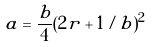Convert formula to latex. <formula><loc_0><loc_0><loc_500><loc_500>a = \frac { b } { 4 } ( 2 r + 1 / b ) ^ { 2 }</formula> 